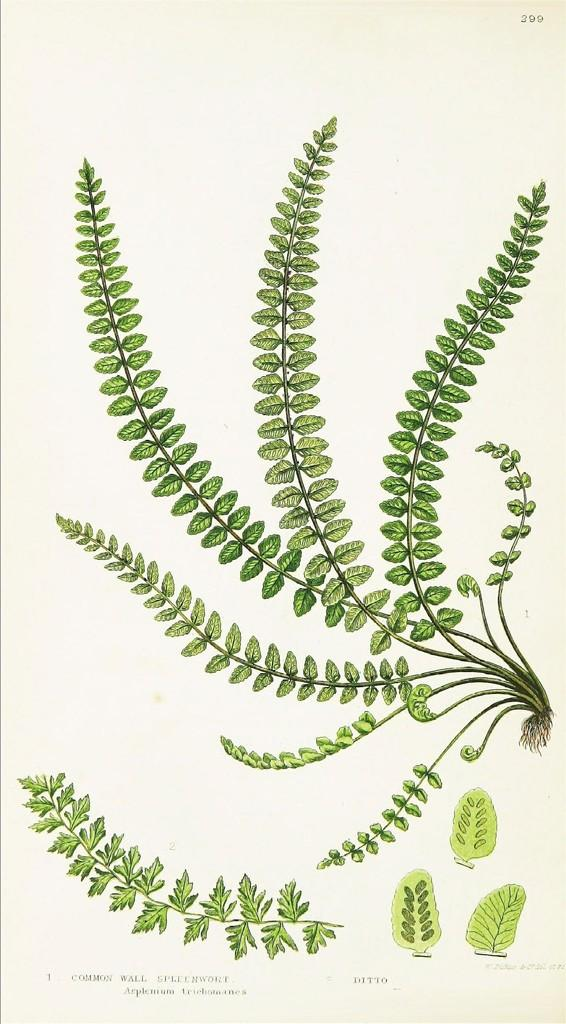What type of editing has been done to the image? The image is edited, but the specific type of editing is not mentioned in the facts. What is depicted in the pictures within the image? There are pictures of a plant and leaves in the image. Where is the text located in the image? The text is at the bottom of the image. Is there a spy hiding among the leaves in the image? There is no mention of a spy or any hidden figures in the image; it only contains pictures of a plant and leaves. 